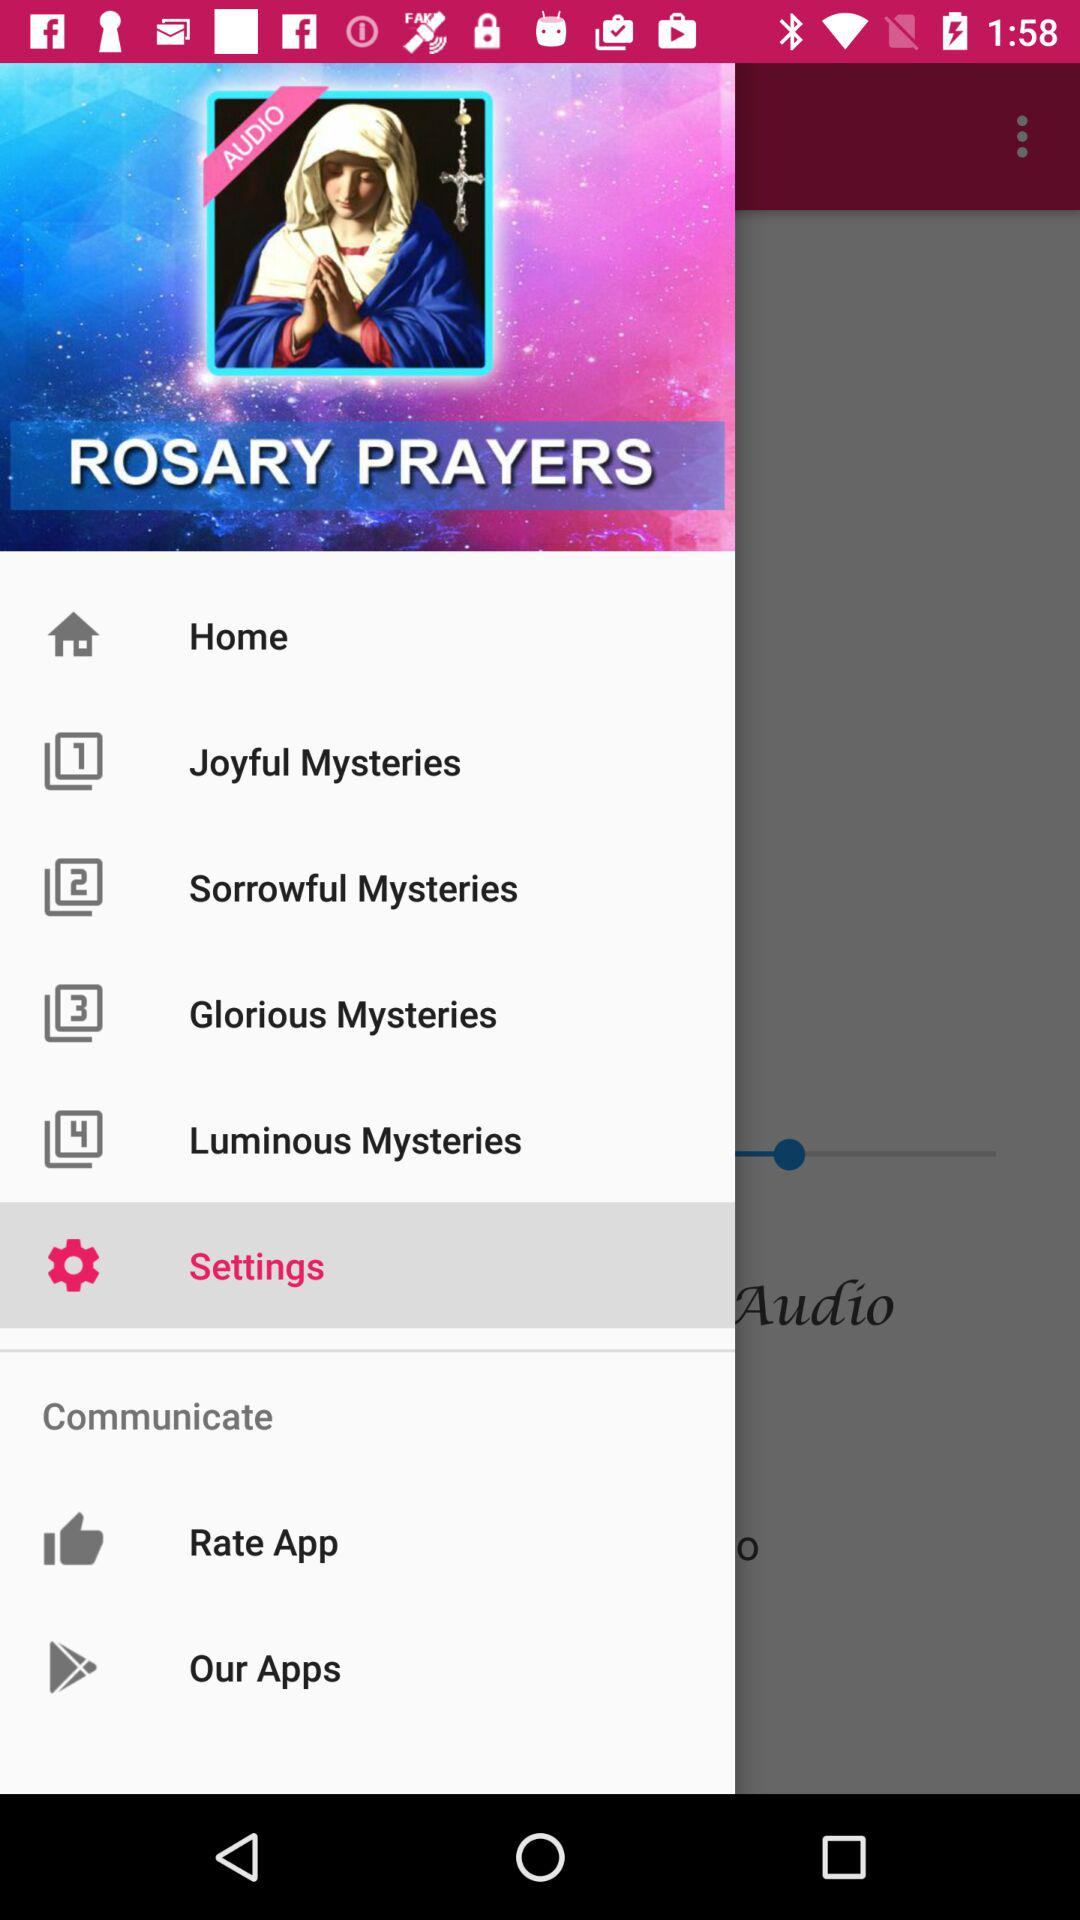What is the application name? The application name is "ROSARY PRAYERS". 